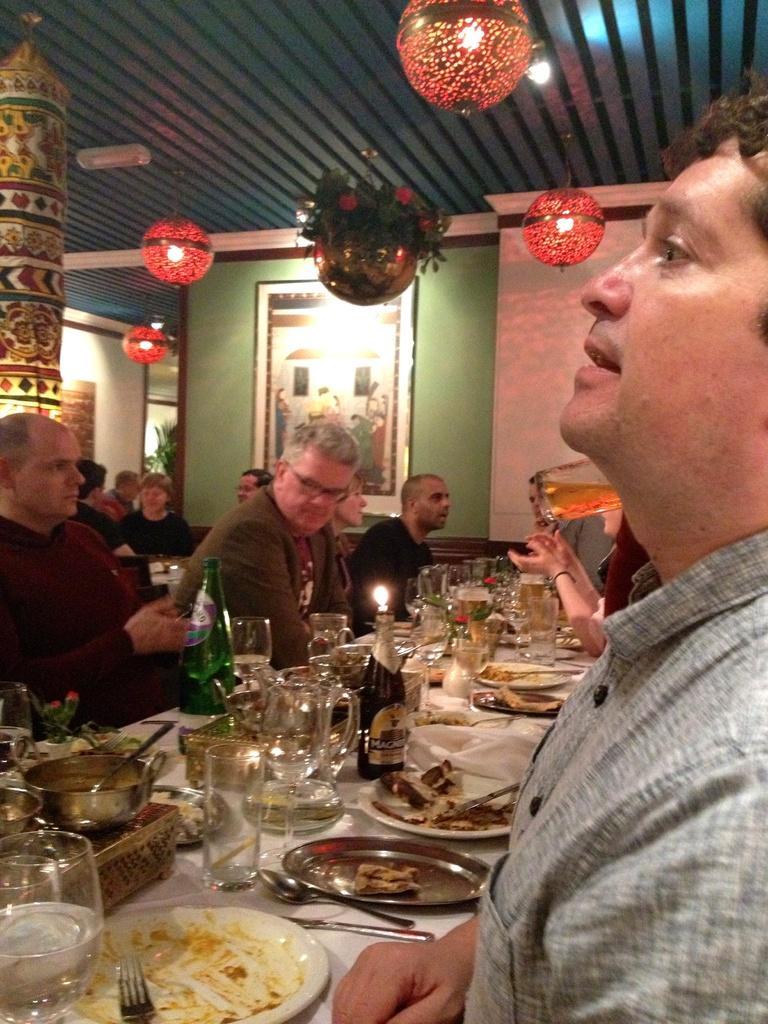Can you describe this image briefly? Here we can see some persons are sitting on the chairs. This is table. On the table there are bottles, glasses, plates, bowls, and spoons. On the background there is a wall and this is frame. These are the lights and this is roof. 